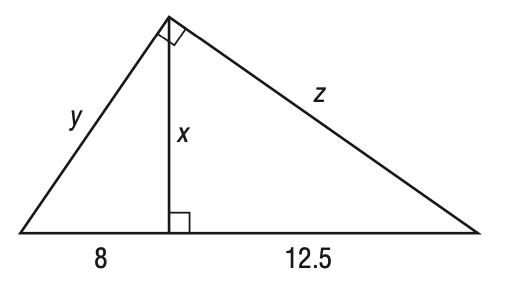Answer the mathemtical geometry problem and directly provide the correct option letter.
Question: Refer to the triangle shown below. Find z to the nearest tenth.
Choices: A: 7.5 B: 10 C: 12.5 D: \frac { 5 } { 2 } \sqrt { 41 } D 